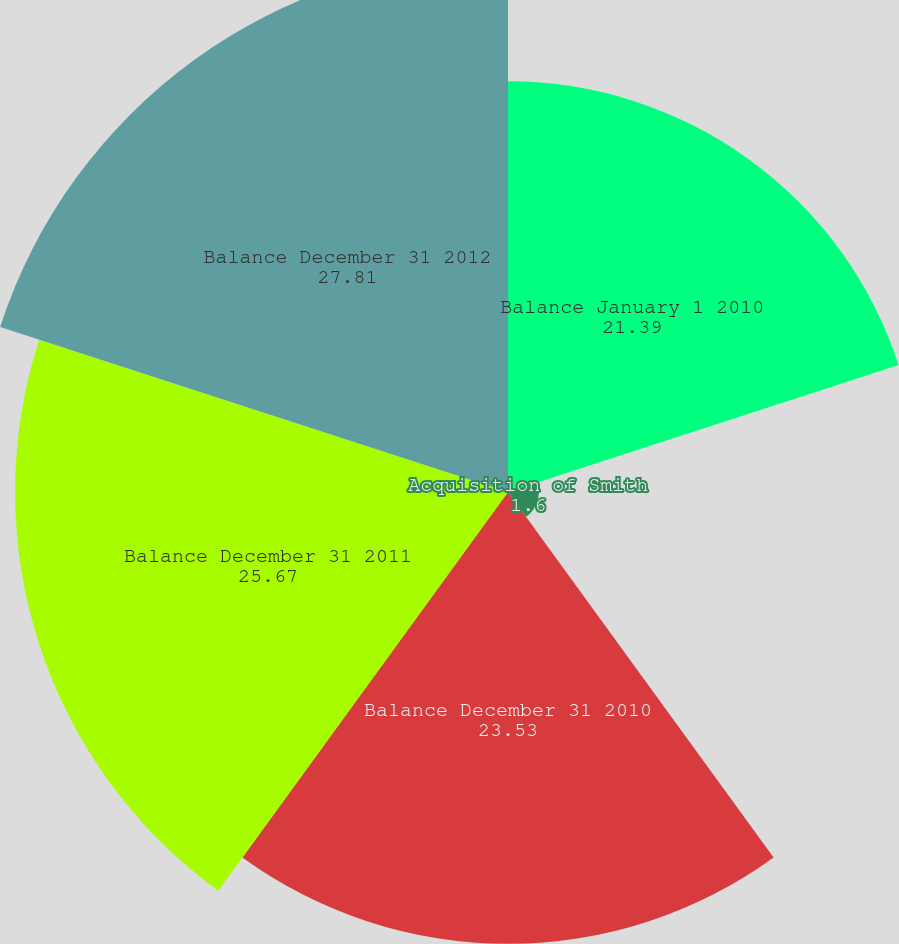Convert chart. <chart><loc_0><loc_0><loc_500><loc_500><pie_chart><fcel>Balance January 1 2010<fcel>Acquisition of Smith<fcel>Balance December 31 2010<fcel>Balance December 31 2011<fcel>Balance December 31 2012<nl><fcel>21.39%<fcel>1.6%<fcel>23.53%<fcel>25.67%<fcel>27.81%<nl></chart> 